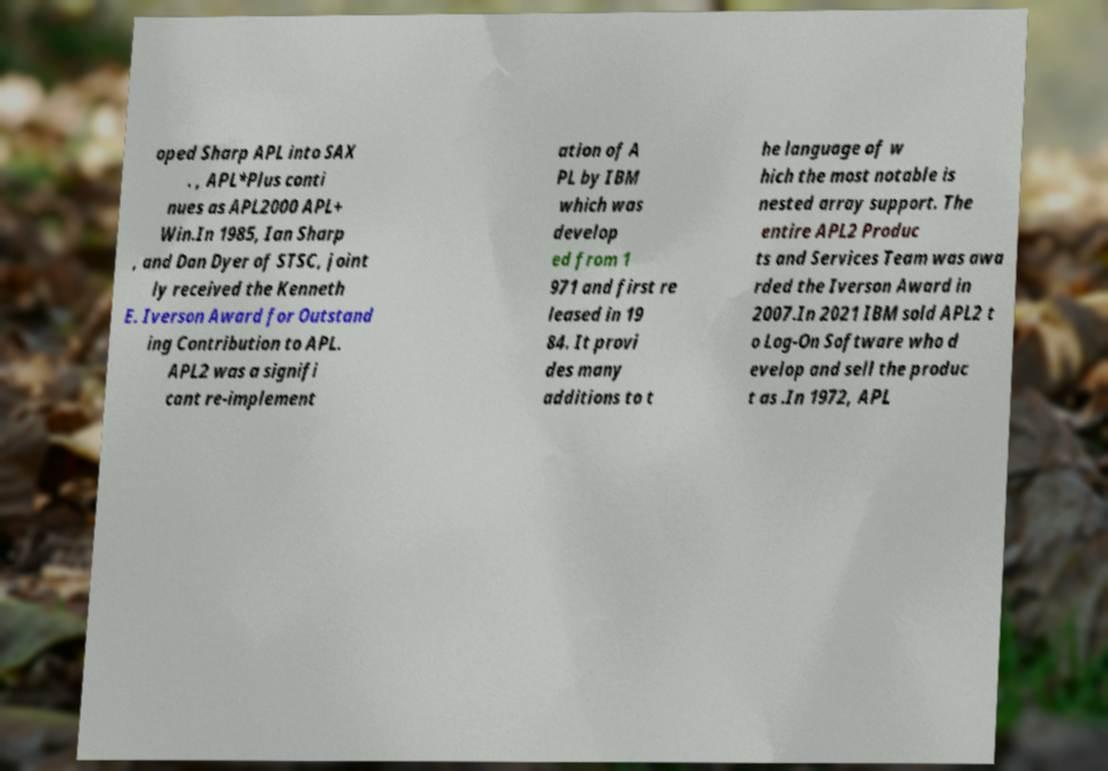For documentation purposes, I need the text within this image transcribed. Could you provide that? oped Sharp APL into SAX . , APL*Plus conti nues as APL2000 APL+ Win.In 1985, Ian Sharp , and Dan Dyer of STSC, joint ly received the Kenneth E. Iverson Award for Outstand ing Contribution to APL. APL2 was a signifi cant re-implement ation of A PL by IBM which was develop ed from 1 971 and first re leased in 19 84. It provi des many additions to t he language of w hich the most notable is nested array support. The entire APL2 Produc ts and Services Team was awa rded the Iverson Award in 2007.In 2021 IBM sold APL2 t o Log-On Software who d evelop and sell the produc t as .In 1972, APL 